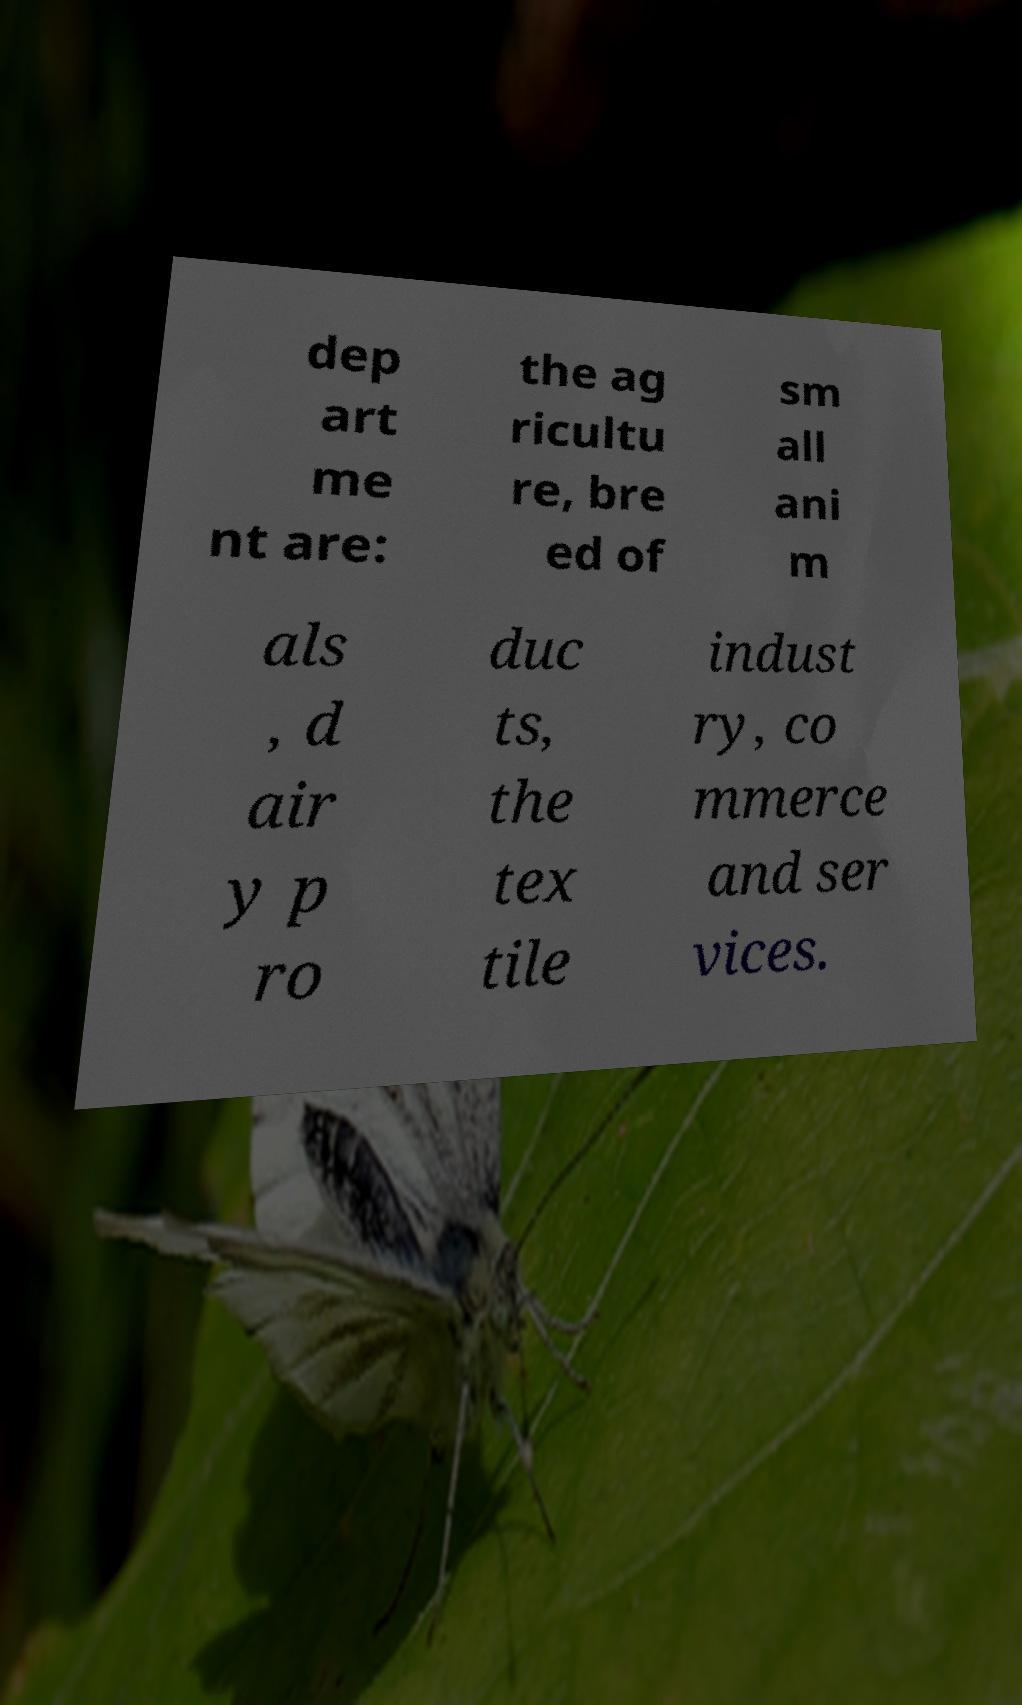There's text embedded in this image that I need extracted. Can you transcribe it verbatim? dep art me nt are: the ag ricultu re, bre ed of sm all ani m als , d air y p ro duc ts, the tex tile indust ry, co mmerce and ser vices. 